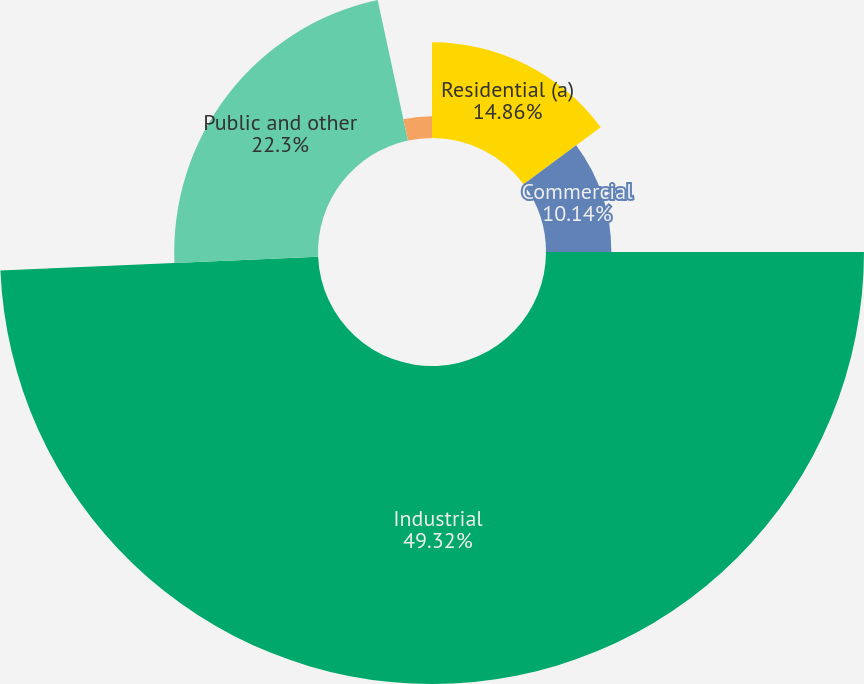Convert chart to OTSL. <chart><loc_0><loc_0><loc_500><loc_500><pie_chart><fcel>Residential (a)<fcel>Commercial<fcel>Industrial<fcel>Public and other<fcel>Billed water services<nl><fcel>14.86%<fcel>10.14%<fcel>49.32%<fcel>22.3%<fcel>3.38%<nl></chart> 